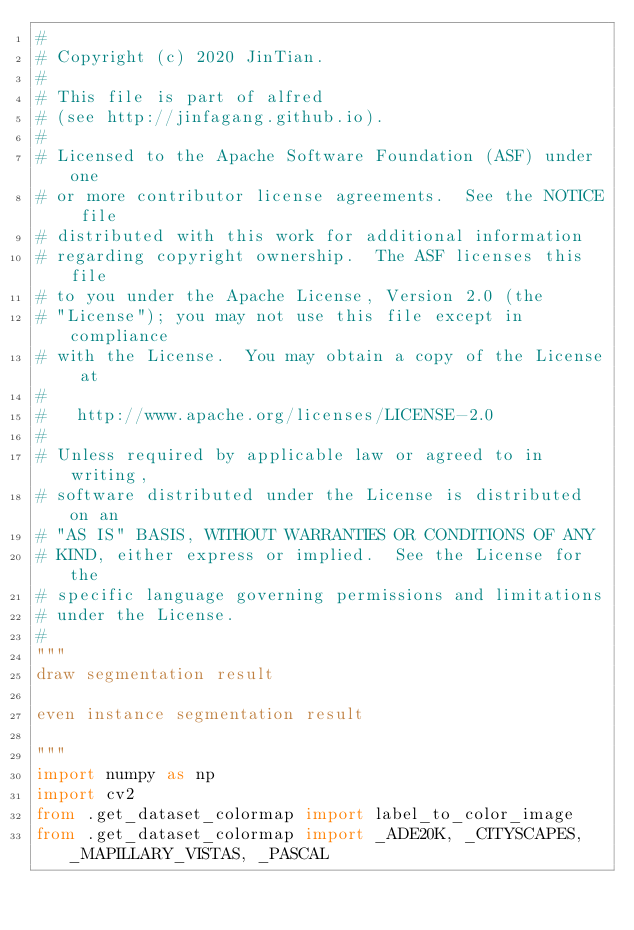<code> <loc_0><loc_0><loc_500><loc_500><_Python_>#
# Copyright (c) 2020 JinTian.
#
# This file is part of alfred
# (see http://jinfagang.github.io).
#
# Licensed to the Apache Software Foundation (ASF) under one
# or more contributor license agreements.  See the NOTICE file
# distributed with this work for additional information
# regarding copyright ownership.  The ASF licenses this file
# to you under the Apache License, Version 2.0 (the
# "License"); you may not use this file except in compliance
# with the License.  You may obtain a copy of the License at
#
#   http://www.apache.org/licenses/LICENSE-2.0
#
# Unless required by applicable law or agreed to in writing,
# software distributed under the License is distributed on an
# "AS IS" BASIS, WITHOUT WARRANTIES OR CONDITIONS OF ANY
# KIND, either express or implied.  See the License for the
# specific language governing permissions and limitations
# under the License.
#
"""
draw segmentation result

even instance segmentation result

"""
import numpy as np
import cv2
from .get_dataset_colormap import label_to_color_image
from .get_dataset_colormap import _ADE20K, _CITYSCAPES, _MAPILLARY_VISTAS, _PASCAL

</code> 